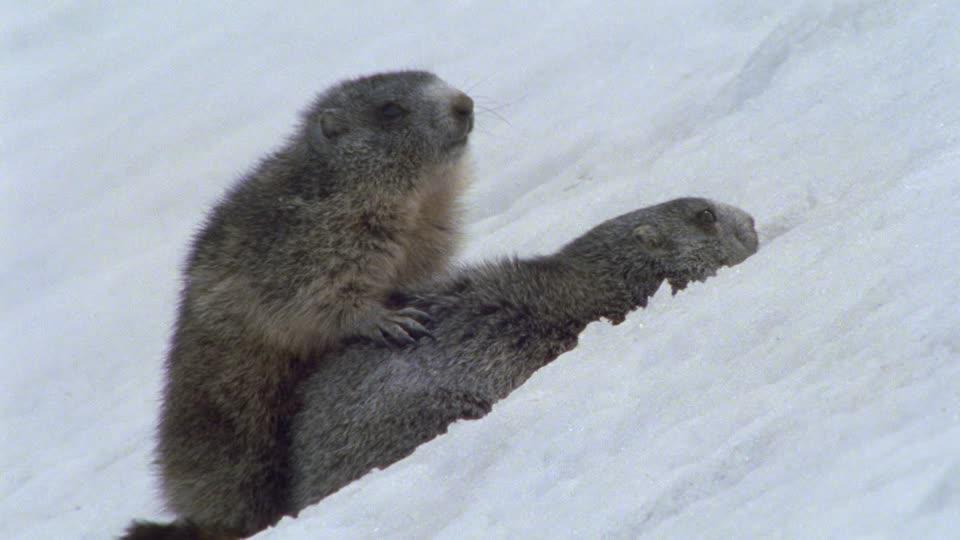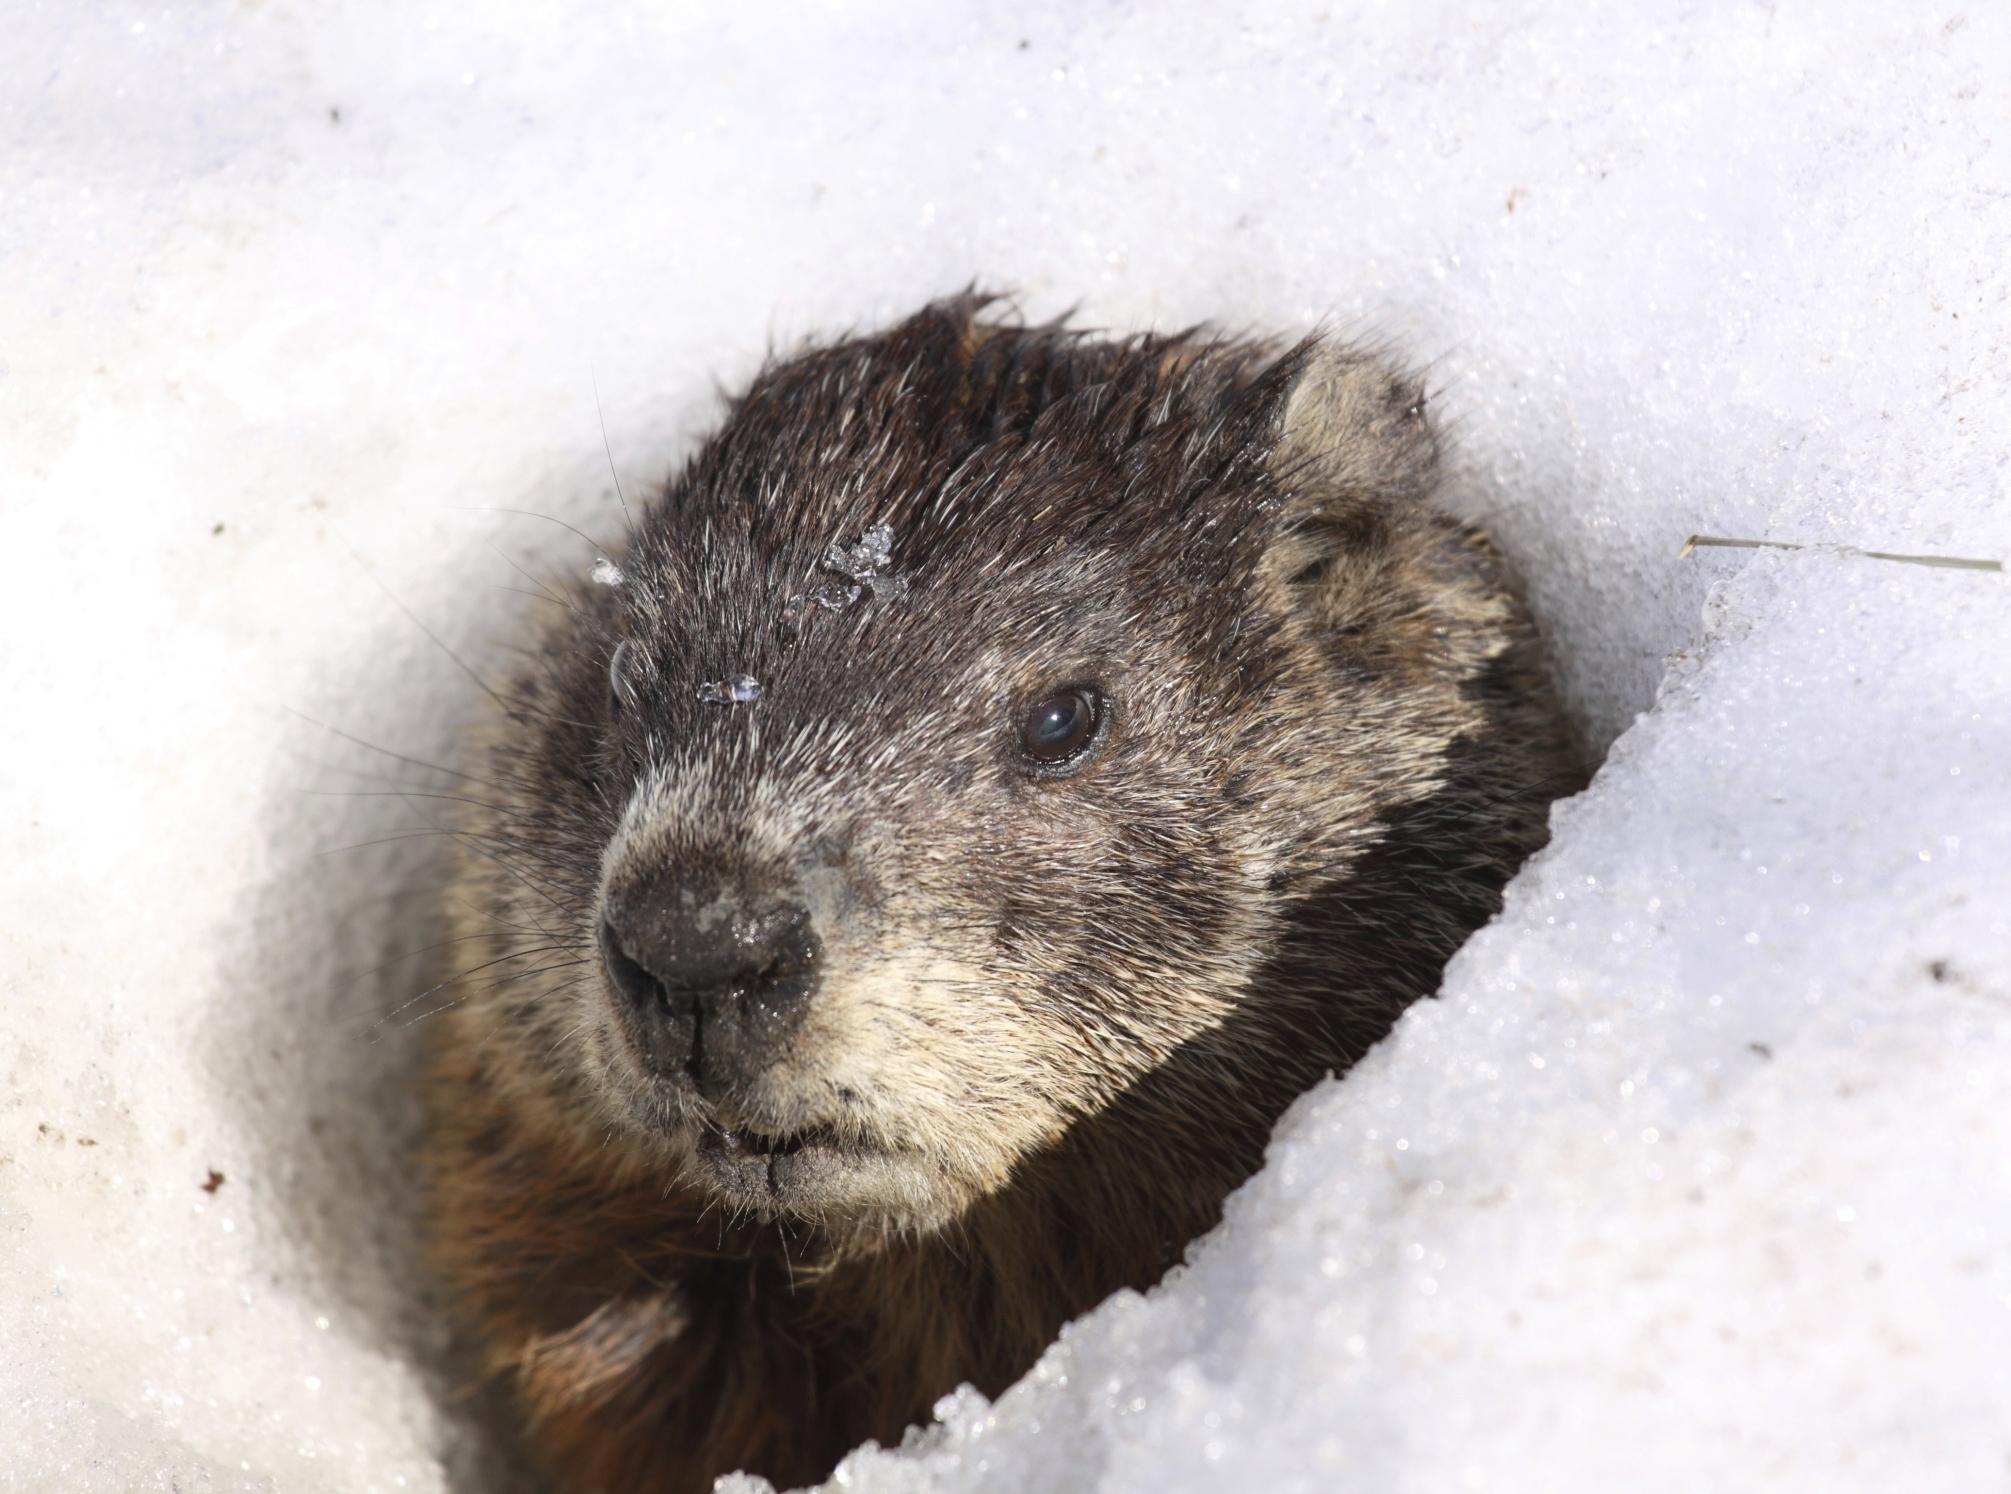The first image is the image on the left, the second image is the image on the right. Evaluate the accuracy of this statement regarding the images: "One image contains twice as many marmots as the other image.". Is it true? Answer yes or no. Yes. 